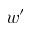Convert formula to latex. <formula><loc_0><loc_0><loc_500><loc_500>w ^ { \prime }</formula> 